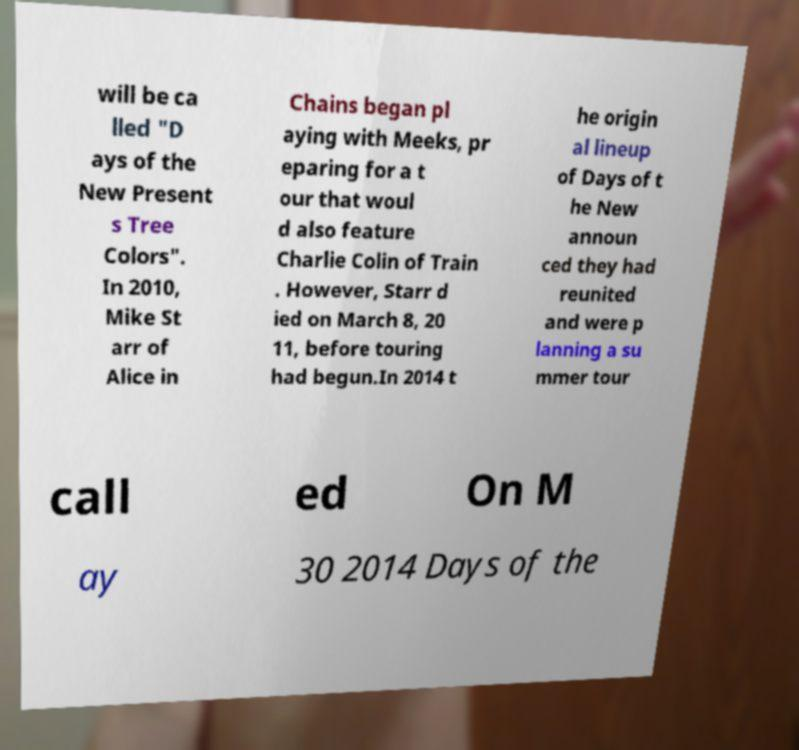Please read and relay the text visible in this image. What does it say? will be ca lled "D ays of the New Present s Tree Colors". In 2010, Mike St arr of Alice in Chains began pl aying with Meeks, pr eparing for a t our that woul d also feature Charlie Colin of Train . However, Starr d ied on March 8, 20 11, before touring had begun.In 2014 t he origin al lineup of Days of t he New announ ced they had reunited and were p lanning a su mmer tour call ed On M ay 30 2014 Days of the 